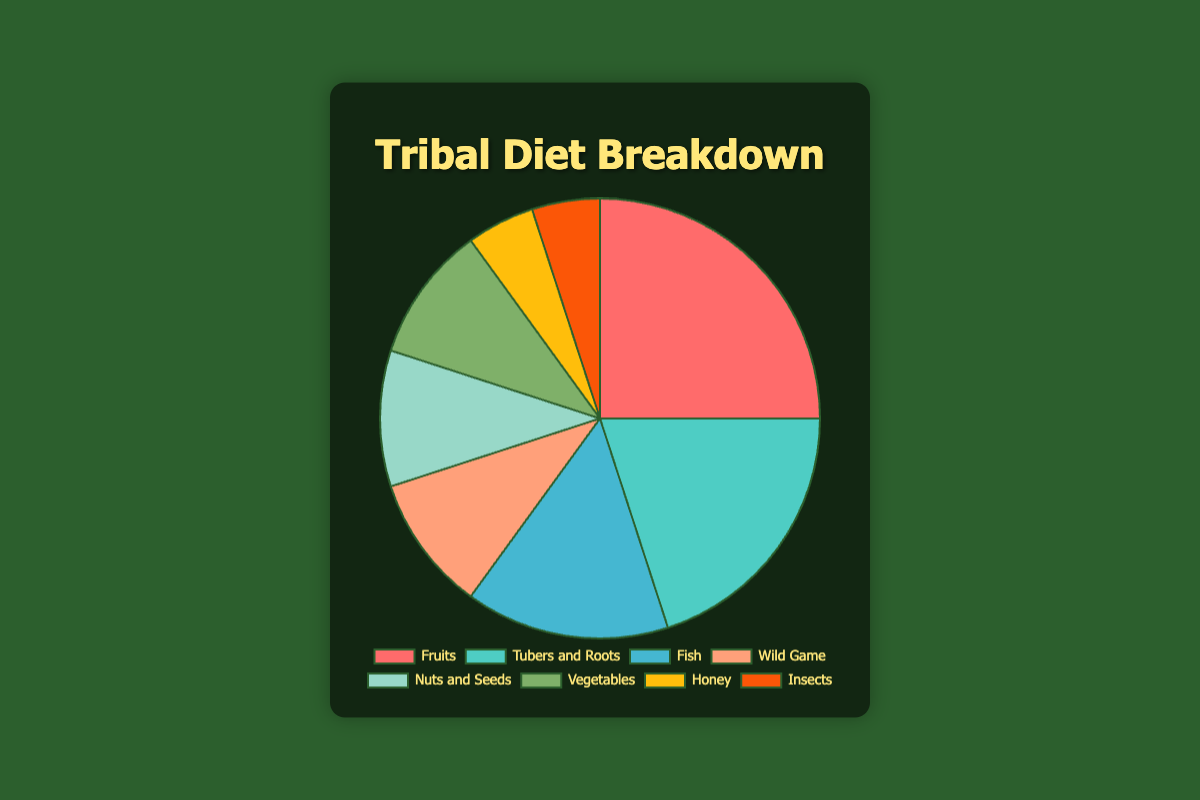Which food source contributes the most to our diet? The pie chart shows that 'Fruits' has the largest portion, marked at 25%. To find this, simply look for the segment with the highest percentage value on the chart.
Answer: Fruits What percentage of our diet comes from fish and wild game combined? First, locate the percentages for 'Fish' and 'Wild Game' on the chart. Then, add these values: 15% (Fish) + 10% (Wild Game) = 25%.
Answer: 25% How do the contributions of 'Honey' and 'Insects' compare? Both 'Honey' and 'Insects' each contribute 5% to the diet. To find this, look at the chart and compare the sizes of the segments for these two food types, noting their equal sizes and percentage values.
Answer: Equal What is the difference in contribution between 'Fruits' and 'Vegetables'? Locate the percentages for 'Fruits' and 'Vegetables' on the chart, then subtract the percentage of 'Vegetables' from 'Fruits': 25% (Fruits) - 10% (Vegetables) = 15%.
Answer: 15% Which two food sources contribute equally to the diet? By examining the percentages on the chart, you can see that 'Wild Game', 'Nuts and Seeds', and 'Vegetables' each contribute 10%. Thus, 'Wild Game' and 'Nuts and Seeds' or 'Wild Game' and 'Vegetables' or 'Nuts and Seeds' and 'Vegetables' contribute equally.
Answer: Wild Game and Nuts and Seeds or Wild Game and Vegetables or Nuts and Seeds and Vegetables If we grouped 'Insects' and 'Honey', how would their combined percentage compare to 'Tubers and Roots'? Add the percentages of 'Insects' and 'Honey': 5% + 5% = 10%. Compare this to 'Tubers and Roots' at 20%. The combined contribution is smaller by 10%.
Answer: Smaller What is the total percentage contributed by non-meat sources (excluding Fish and Wild Game)? Add the percentages for non-meat sources 'Fruits', 'Tubers and Roots', 'Nuts and Seeds', 'Vegetables', 'Honey', and 'Insects': 25% + 20% + 10% + 10% + 5% + 5% = 75%.
Answer: 75% Which source has the smallest contribution to the diet? The chart shows that both 'Honey' and 'Insects' each have a 5% contribution, which is the smallest.
Answer: Honey and Insects What is the average percentage contribution of all the food sources? Add all the percentages: 25 + 20 + 15 + 10 + 10 + 10 + 5 + 5 = 100. Then, divide by the number of food sources, which is 8: 100 / 8 = 12.5%.
Answer: 12.5% How many food sources have a 10% contribution to the diet? Look at the chart for segments marked 10%. There are three food sources: 'Wild Game', 'Nuts and Seeds', and 'Vegetables'.
Answer: 3 